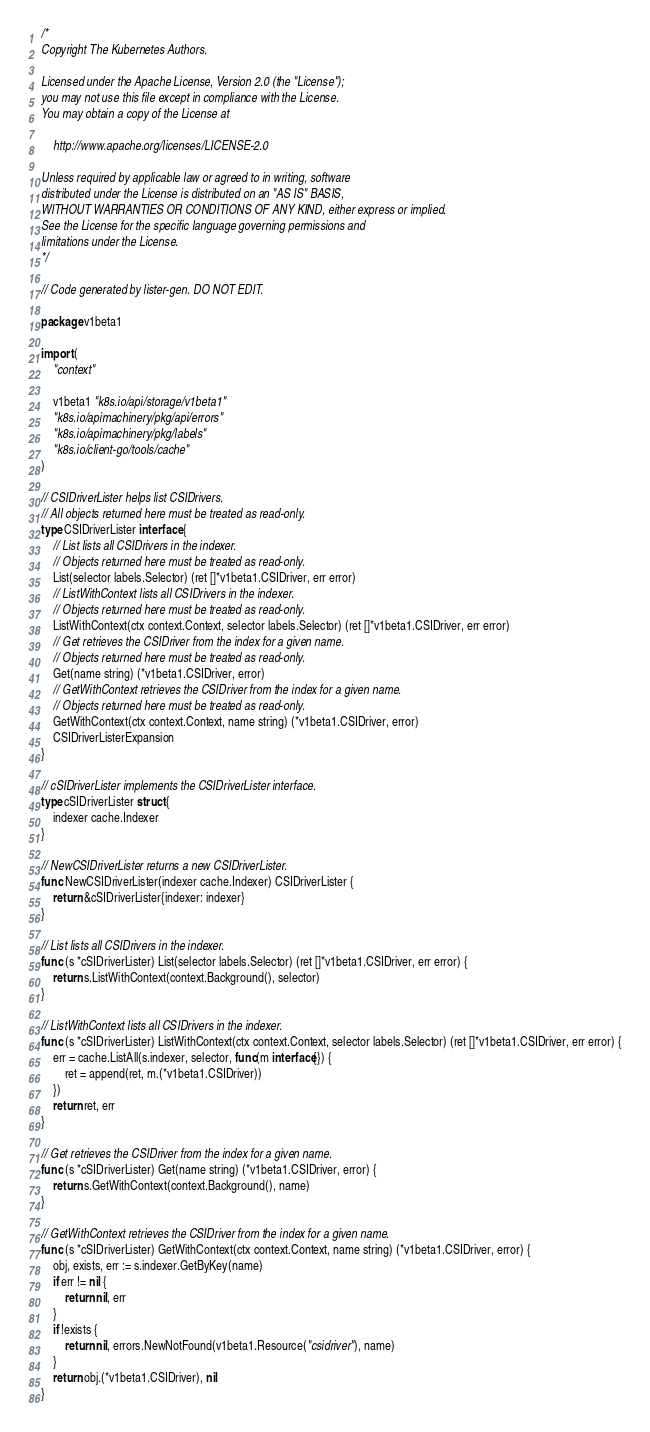Convert code to text. <code><loc_0><loc_0><loc_500><loc_500><_Go_>/*
Copyright The Kubernetes Authors.

Licensed under the Apache License, Version 2.0 (the "License");
you may not use this file except in compliance with the License.
You may obtain a copy of the License at

    http://www.apache.org/licenses/LICENSE-2.0

Unless required by applicable law or agreed to in writing, software
distributed under the License is distributed on an "AS IS" BASIS,
WITHOUT WARRANTIES OR CONDITIONS OF ANY KIND, either express or implied.
See the License for the specific language governing permissions and
limitations under the License.
*/

// Code generated by lister-gen. DO NOT EDIT.

package v1beta1

import (
	"context"

	v1beta1 "k8s.io/api/storage/v1beta1"
	"k8s.io/apimachinery/pkg/api/errors"
	"k8s.io/apimachinery/pkg/labels"
	"k8s.io/client-go/tools/cache"
)

// CSIDriverLister helps list CSIDrivers.
// All objects returned here must be treated as read-only.
type CSIDriverLister interface {
	// List lists all CSIDrivers in the indexer.
	// Objects returned here must be treated as read-only.
	List(selector labels.Selector) (ret []*v1beta1.CSIDriver, err error)
	// ListWithContext lists all CSIDrivers in the indexer.
	// Objects returned here must be treated as read-only.
	ListWithContext(ctx context.Context, selector labels.Selector) (ret []*v1beta1.CSIDriver, err error)
	// Get retrieves the CSIDriver from the index for a given name.
	// Objects returned here must be treated as read-only.
	Get(name string) (*v1beta1.CSIDriver, error)
	// GetWithContext retrieves the CSIDriver from the index for a given name.
	// Objects returned here must be treated as read-only.
	GetWithContext(ctx context.Context, name string) (*v1beta1.CSIDriver, error)
	CSIDriverListerExpansion
}

// cSIDriverLister implements the CSIDriverLister interface.
type cSIDriverLister struct {
	indexer cache.Indexer
}

// NewCSIDriverLister returns a new CSIDriverLister.
func NewCSIDriverLister(indexer cache.Indexer) CSIDriverLister {
	return &cSIDriverLister{indexer: indexer}
}

// List lists all CSIDrivers in the indexer.
func (s *cSIDriverLister) List(selector labels.Selector) (ret []*v1beta1.CSIDriver, err error) {
	return s.ListWithContext(context.Background(), selector)
}

// ListWithContext lists all CSIDrivers in the indexer.
func (s *cSIDriverLister) ListWithContext(ctx context.Context, selector labels.Selector) (ret []*v1beta1.CSIDriver, err error) {
	err = cache.ListAll(s.indexer, selector, func(m interface{}) {
		ret = append(ret, m.(*v1beta1.CSIDriver))
	})
	return ret, err
}

// Get retrieves the CSIDriver from the index for a given name.
func (s *cSIDriverLister) Get(name string) (*v1beta1.CSIDriver, error) {
	return s.GetWithContext(context.Background(), name)
}

// GetWithContext retrieves the CSIDriver from the index for a given name.
func (s *cSIDriverLister) GetWithContext(ctx context.Context, name string) (*v1beta1.CSIDriver, error) {
	obj, exists, err := s.indexer.GetByKey(name)
	if err != nil {
		return nil, err
	}
	if !exists {
		return nil, errors.NewNotFound(v1beta1.Resource("csidriver"), name)
	}
	return obj.(*v1beta1.CSIDriver), nil
}
</code> 